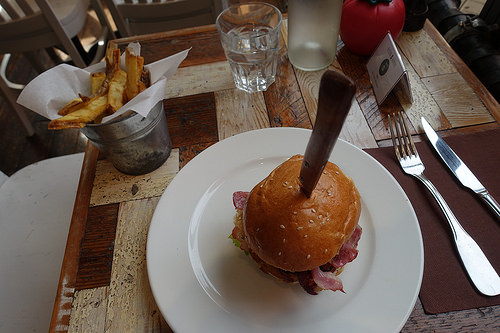<image>
Can you confirm if the fries is behind the knife? No. The fries is not behind the knife. From this viewpoint, the fries appears to be positioned elsewhere in the scene. 